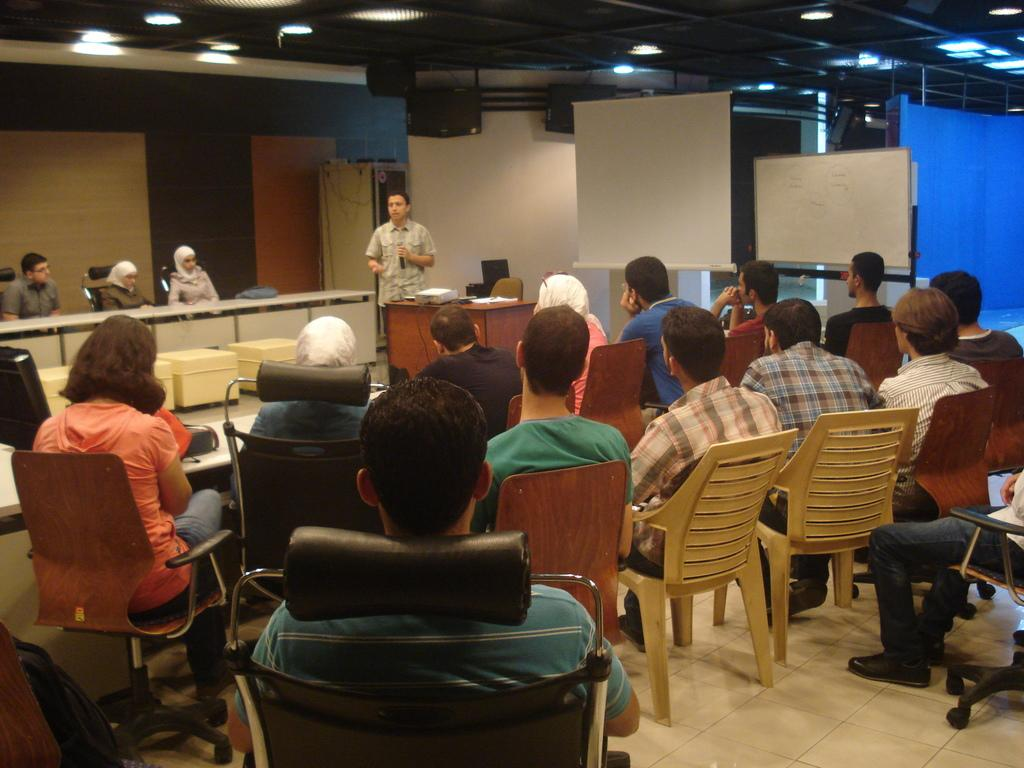What are the people in the image doing? The people in the image are sitting on chairs. Can you describe the man in the image? The man in the image is holding a camera in his hand. What type of arch can be seen in the image? There is no arch present in the image. What color is the plastic wire in the image? There is no plastic wire present in the image. 